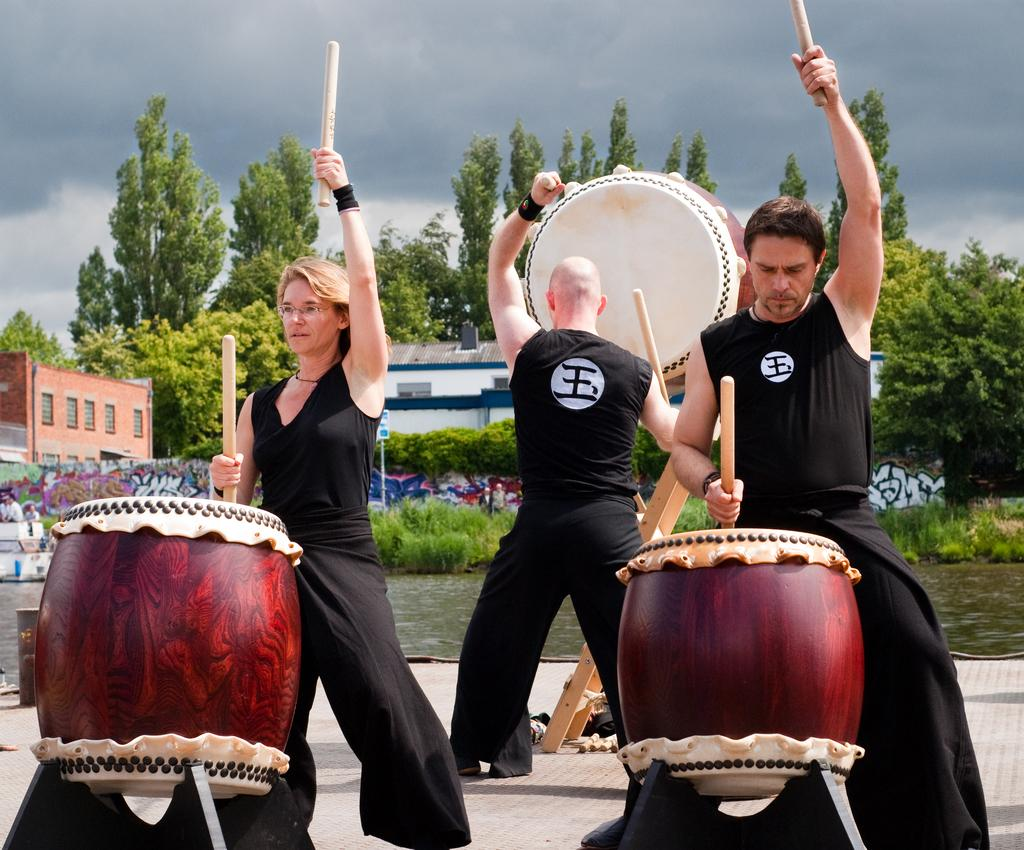What are the people in the image doing? The people in the image are beating the drums. How many people are beating the drums in the image? There are three people beating the drums in the image. What can be seen in the background of the image? In the background of the image, there are trees, a building, plants, a pole, the sky, and water. What type of temper does the woman have while beating the drums in the image? There is no indication of the woman's temper in the image; she is simply beating the drums. What type of trade is being conducted in the image? There is no trade being conducted in the image; it features people beating drums and a background setting. 